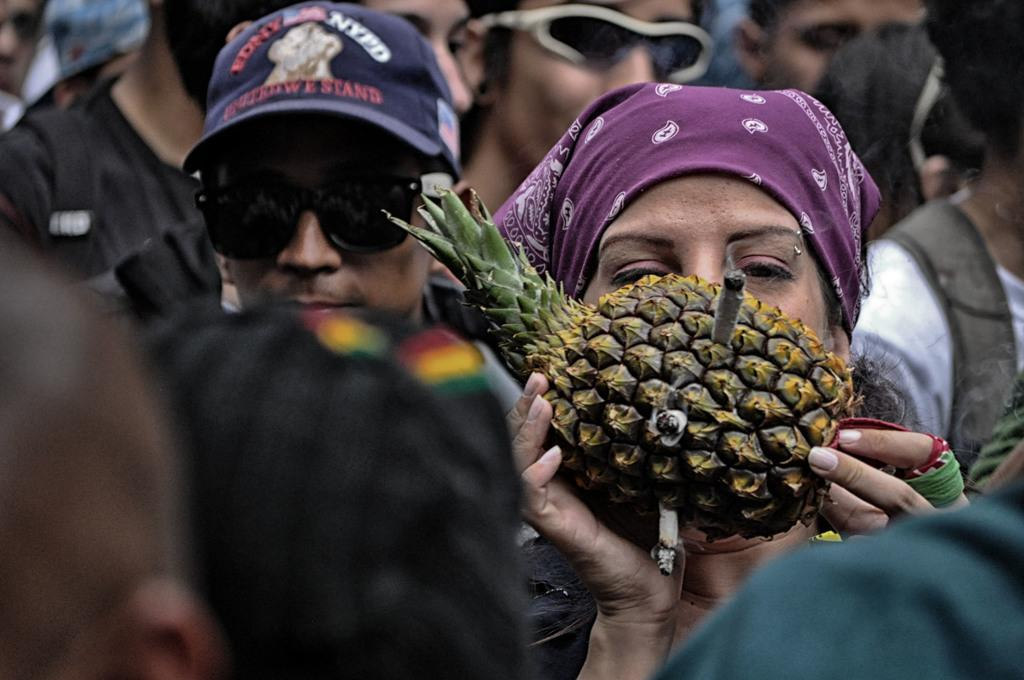Who is the main subject in the image? There is a lady in the image. What is the lady holding in the image? The lady is holding a pineapple. What is happening with the pineapple? Cigarettes are plucked inside the pineapple. Are there any other people in the image? Yes, there are people standing behind the lady. What type of jam is being spread on the bread in the image? There is no bread or jam present in the image; it features a lady holding a pineapple with cigarettes plucked inside it. 